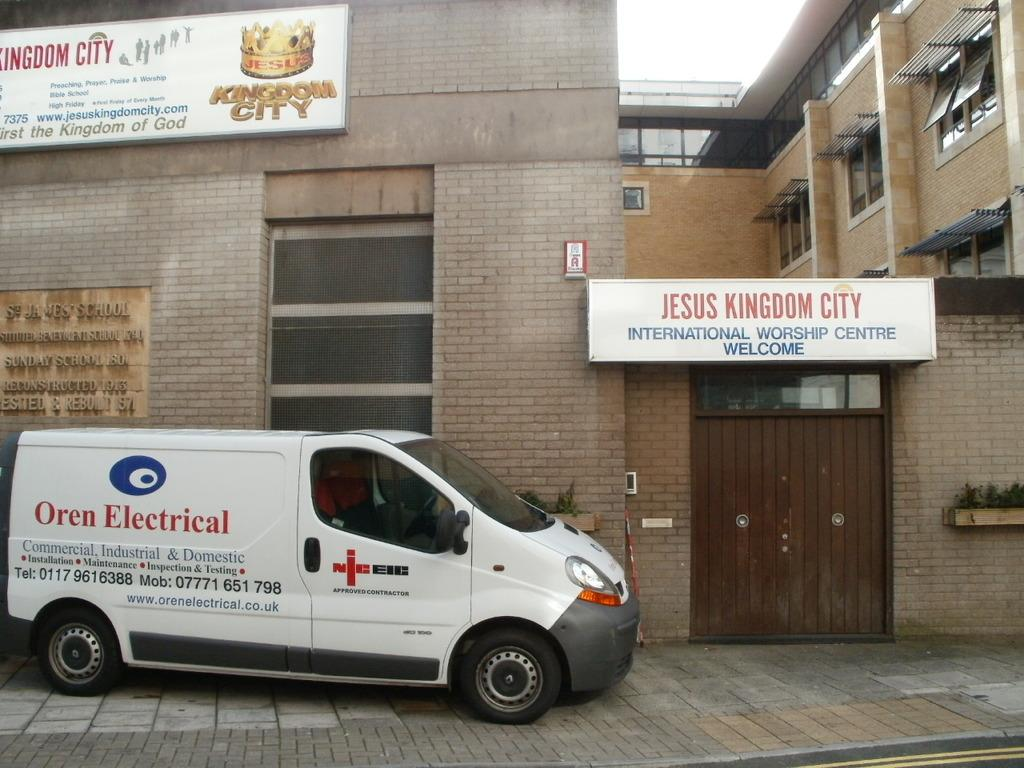<image>
Summarize the visual content of the image. a sign that says jesus kingdom city on it 